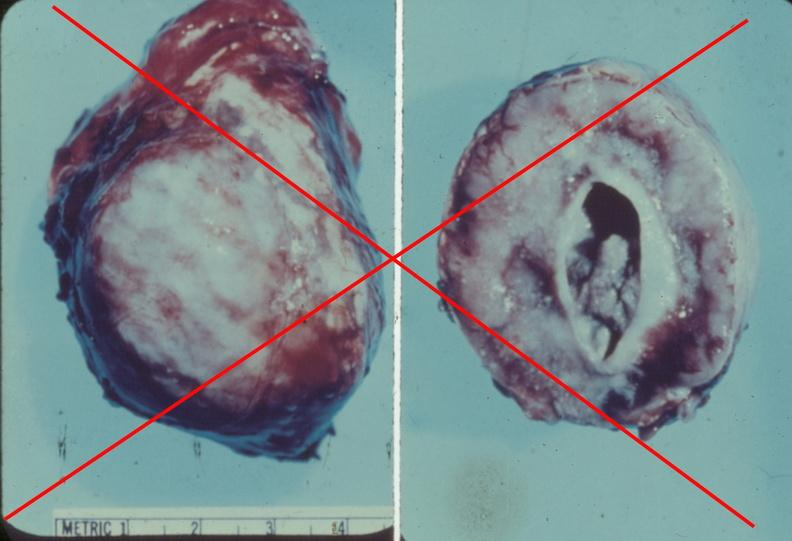what does this image show?
Answer the question using a single word or phrase. Adrenal phaeochromocytoma 